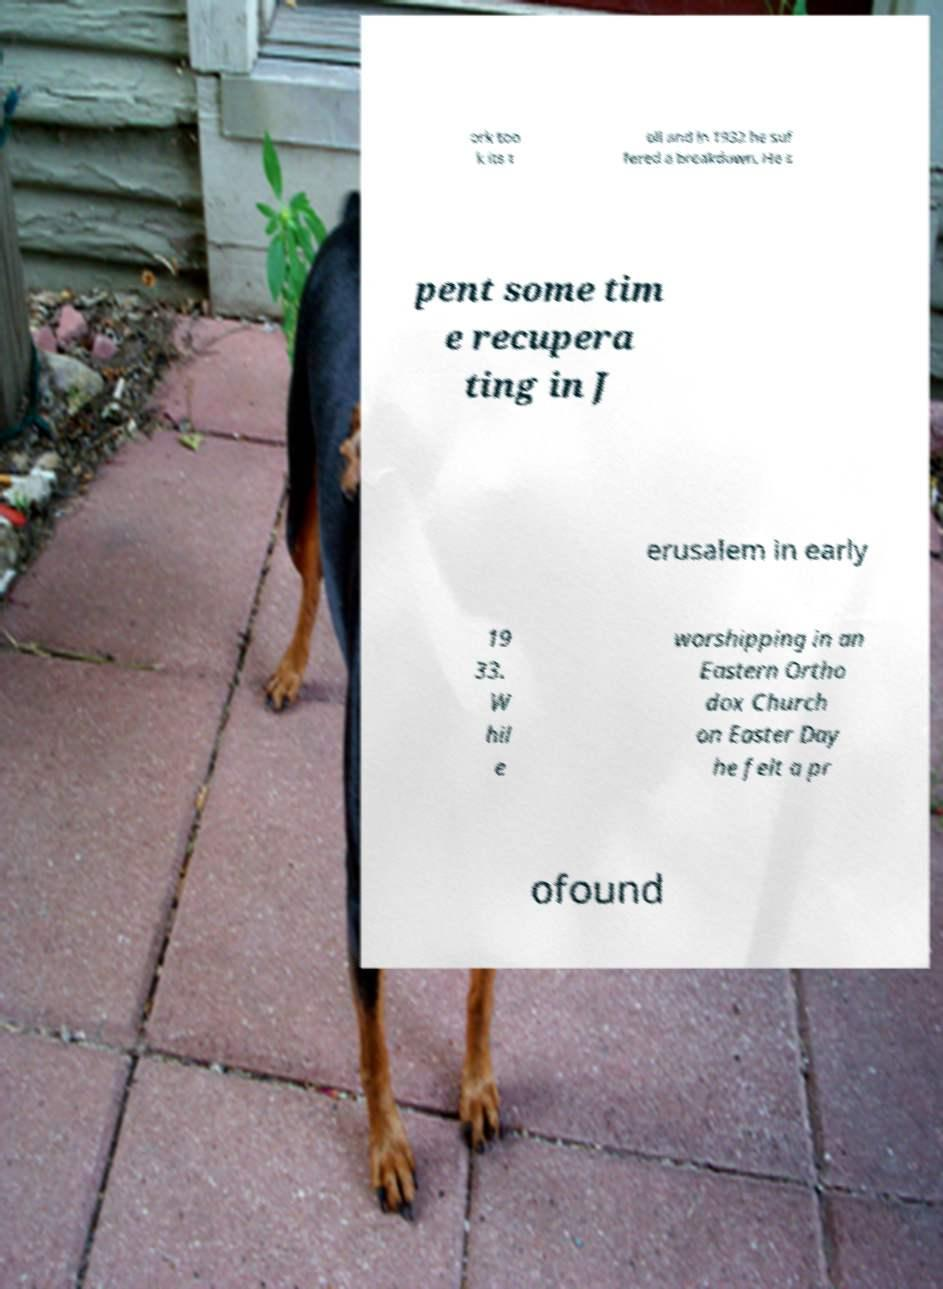For documentation purposes, I need the text within this image transcribed. Could you provide that? ork too k its t oll and in 1932 he suf fered a breakdown. He s pent some tim e recupera ting in J erusalem in early 19 33. W hil e worshipping in an Eastern Ortho dox Church on Easter Day he felt a pr ofound 